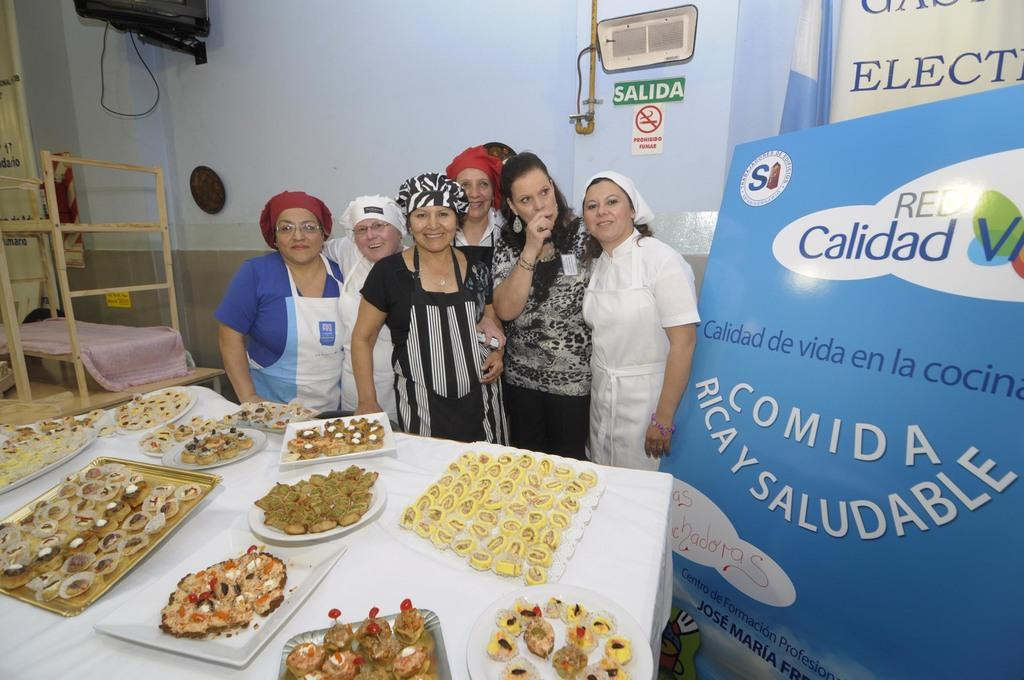What can be seen in the image regarding people? There are women standing in the image. What type of objects are present on a plate in the image? There are food items on a plate in the image. What kind of structure is visible in the image? There is a wall in the image. What is hanging on the wall in the image? There is a poster in the image. What type of cloth is being used by the farmer in the image? There is no farmer or cloth present in the image. 